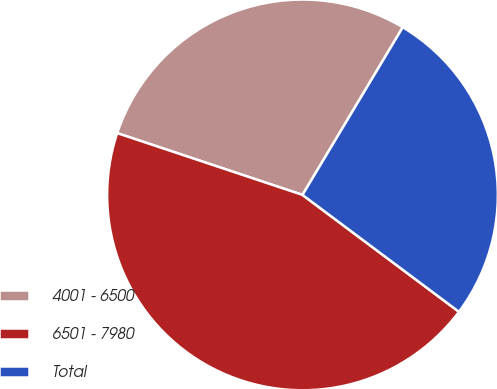Convert chart to OTSL. <chart><loc_0><loc_0><loc_500><loc_500><pie_chart><fcel>4001 - 6500<fcel>6501 - 7980<fcel>Total<nl><fcel>28.46%<fcel>44.91%<fcel>26.63%<nl></chart> 